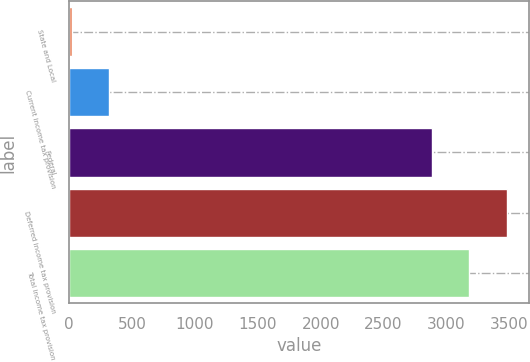<chart> <loc_0><loc_0><loc_500><loc_500><bar_chart><fcel>State and Local<fcel>Current income tax provision<fcel>Federal<fcel>Deferred income tax provision<fcel>Total income tax provision<nl><fcel>20<fcel>319.4<fcel>2884<fcel>3482.8<fcel>3183.4<nl></chart> 